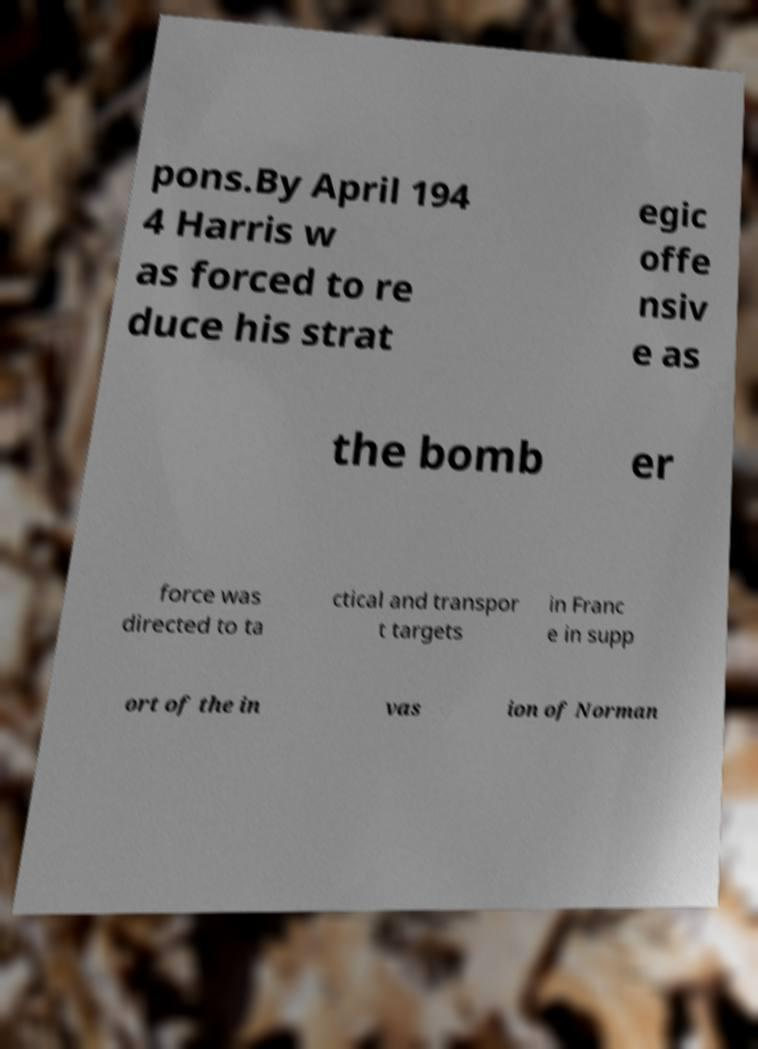For documentation purposes, I need the text within this image transcribed. Could you provide that? pons.By April 194 4 Harris w as forced to re duce his strat egic offe nsiv e as the bomb er force was directed to ta ctical and transpor t targets in Franc e in supp ort of the in vas ion of Norman 